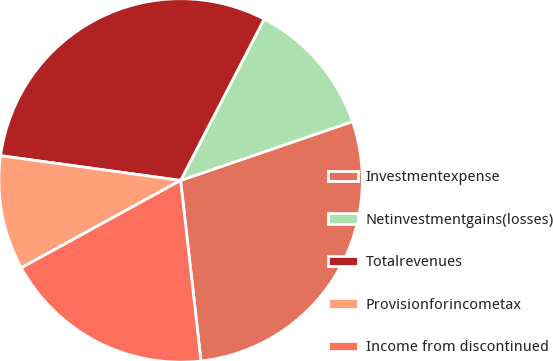<chart> <loc_0><loc_0><loc_500><loc_500><pie_chart><fcel>Investmentexpense<fcel>Netinvestmentgains(losses)<fcel>Totalrevenues<fcel>Provisionforincometax<fcel>Income from discontinued<nl><fcel>28.46%<fcel>12.14%<fcel>30.43%<fcel>10.16%<fcel>18.8%<nl></chart> 